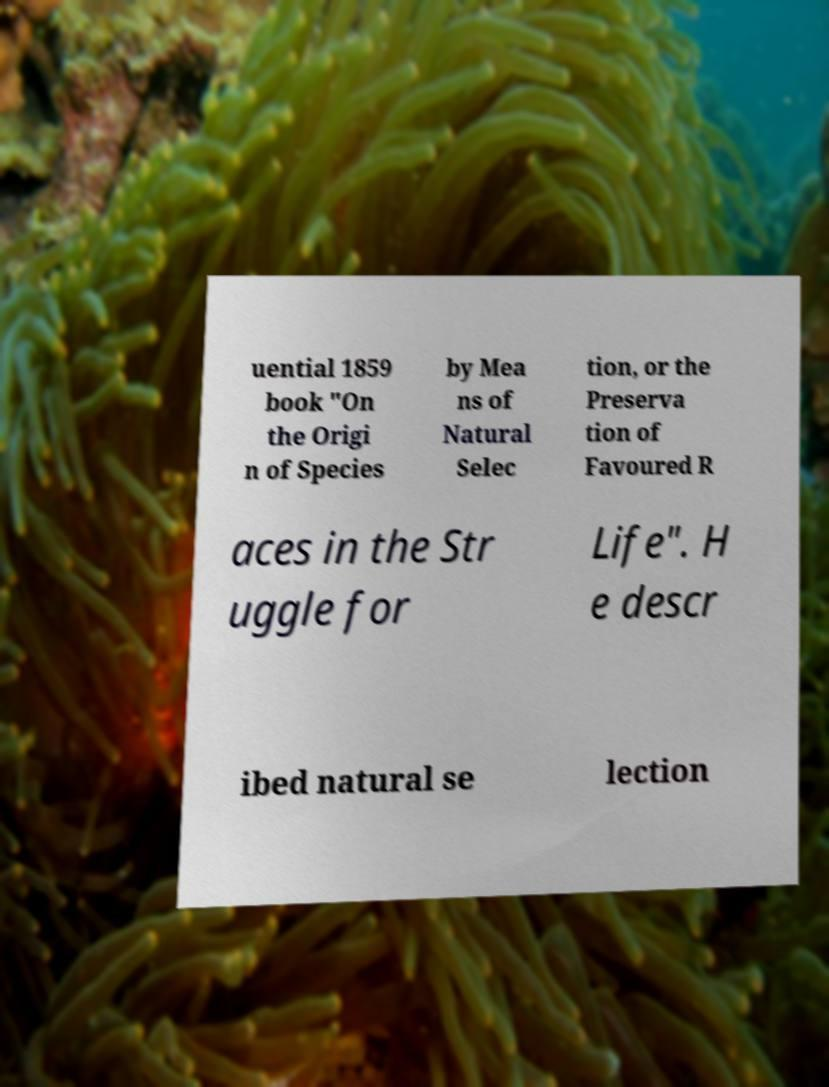Please read and relay the text visible in this image. What does it say? uential 1859 book "On the Origi n of Species by Mea ns of Natural Selec tion, or the Preserva tion of Favoured R aces in the Str uggle for Life". H e descr ibed natural se lection 